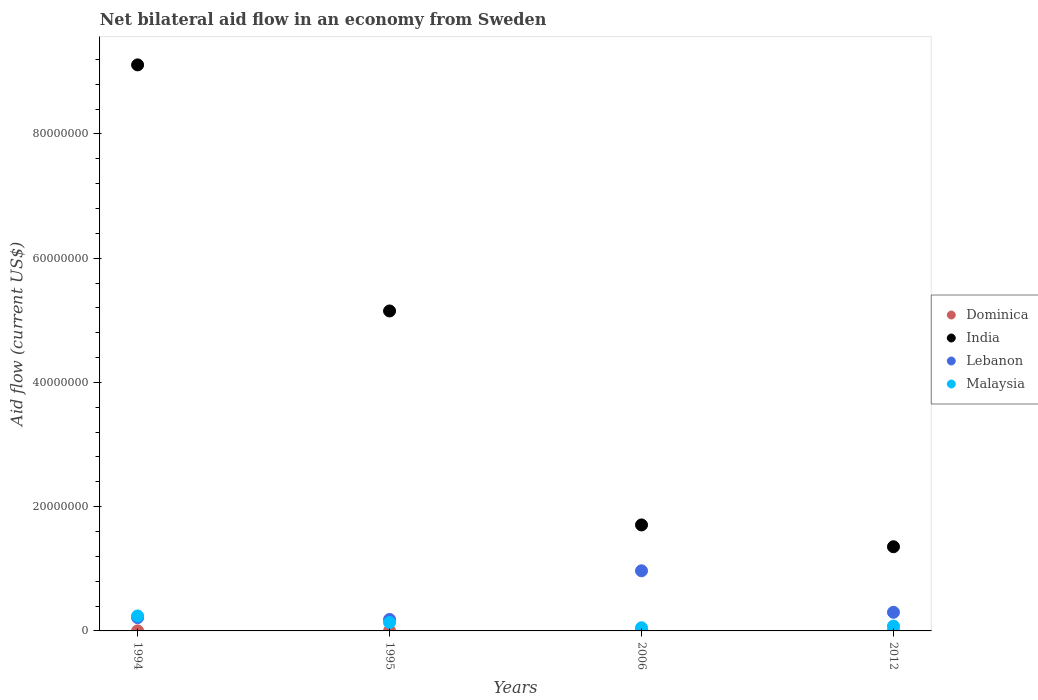How many different coloured dotlines are there?
Ensure brevity in your answer.  4. What is the net bilateral aid flow in India in 1995?
Ensure brevity in your answer.  5.15e+07. Across all years, what is the minimum net bilateral aid flow in Lebanon?
Your answer should be very brief. 1.85e+06. In which year was the net bilateral aid flow in India maximum?
Provide a succinct answer. 1994. What is the total net bilateral aid flow in Lebanon in the graph?
Give a very brief answer. 1.67e+07. What is the difference between the net bilateral aid flow in India in 1995 and that in 2012?
Your answer should be very brief. 3.80e+07. What is the difference between the net bilateral aid flow in Malaysia in 2006 and the net bilateral aid flow in India in 2012?
Offer a very short reply. -1.30e+07. What is the average net bilateral aid flow in Malaysia per year?
Keep it short and to the point. 1.26e+06. In the year 2006, what is the difference between the net bilateral aid flow in Malaysia and net bilateral aid flow in Lebanon?
Your response must be concise. -9.17e+06. In how many years, is the net bilateral aid flow in India greater than 16000000 US$?
Ensure brevity in your answer.  3. What is the ratio of the net bilateral aid flow in Lebanon in 1994 to that in 1995?
Give a very brief answer. 1.16. What is the difference between the highest and the second highest net bilateral aid flow in Lebanon?
Offer a very short reply. 6.68e+06. What is the difference between the highest and the lowest net bilateral aid flow in Dominica?
Provide a short and direct response. 2.00e+04. Is it the case that in every year, the sum of the net bilateral aid flow in Dominica and net bilateral aid flow in Lebanon  is greater than the net bilateral aid flow in India?
Ensure brevity in your answer.  No. Does the net bilateral aid flow in India monotonically increase over the years?
Provide a short and direct response. No. How many dotlines are there?
Make the answer very short. 4. Are the values on the major ticks of Y-axis written in scientific E-notation?
Provide a short and direct response. No. Does the graph contain grids?
Your answer should be very brief. No. Where does the legend appear in the graph?
Make the answer very short. Center right. How many legend labels are there?
Give a very brief answer. 4. What is the title of the graph?
Your answer should be very brief. Net bilateral aid flow in an economy from Sweden. Does "Kazakhstan" appear as one of the legend labels in the graph?
Give a very brief answer. No. What is the Aid flow (current US$) of India in 1994?
Your answer should be very brief. 9.11e+07. What is the Aid flow (current US$) in Lebanon in 1994?
Your response must be concise. 2.14e+06. What is the Aid flow (current US$) of Malaysia in 1994?
Offer a terse response. 2.41e+06. What is the Aid flow (current US$) in India in 1995?
Your answer should be very brief. 5.15e+07. What is the Aid flow (current US$) in Lebanon in 1995?
Ensure brevity in your answer.  1.85e+06. What is the Aid flow (current US$) in Malaysia in 1995?
Keep it short and to the point. 1.35e+06. What is the Aid flow (current US$) of Dominica in 2006?
Keep it short and to the point. 3.00e+04. What is the Aid flow (current US$) in India in 2006?
Provide a succinct answer. 1.71e+07. What is the Aid flow (current US$) of Lebanon in 2006?
Provide a succinct answer. 9.68e+06. What is the Aid flow (current US$) of Malaysia in 2006?
Offer a terse response. 5.10e+05. What is the Aid flow (current US$) in Dominica in 2012?
Keep it short and to the point. 2.00e+04. What is the Aid flow (current US$) of India in 2012?
Your answer should be compact. 1.36e+07. What is the Aid flow (current US$) of Malaysia in 2012?
Make the answer very short. 7.80e+05. Across all years, what is the maximum Aid flow (current US$) of Dominica?
Your answer should be compact. 3.00e+04. Across all years, what is the maximum Aid flow (current US$) in India?
Your answer should be very brief. 9.11e+07. Across all years, what is the maximum Aid flow (current US$) in Lebanon?
Make the answer very short. 9.68e+06. Across all years, what is the maximum Aid flow (current US$) of Malaysia?
Provide a short and direct response. 2.41e+06. Across all years, what is the minimum Aid flow (current US$) of Dominica?
Keep it short and to the point. 10000. Across all years, what is the minimum Aid flow (current US$) in India?
Provide a succinct answer. 1.36e+07. Across all years, what is the minimum Aid flow (current US$) of Lebanon?
Ensure brevity in your answer.  1.85e+06. Across all years, what is the minimum Aid flow (current US$) in Malaysia?
Give a very brief answer. 5.10e+05. What is the total Aid flow (current US$) of India in the graph?
Offer a terse response. 1.73e+08. What is the total Aid flow (current US$) of Lebanon in the graph?
Offer a terse response. 1.67e+07. What is the total Aid flow (current US$) in Malaysia in the graph?
Provide a short and direct response. 5.05e+06. What is the difference between the Aid flow (current US$) of Dominica in 1994 and that in 1995?
Make the answer very short. -10000. What is the difference between the Aid flow (current US$) of India in 1994 and that in 1995?
Make the answer very short. 3.96e+07. What is the difference between the Aid flow (current US$) of Malaysia in 1994 and that in 1995?
Keep it short and to the point. 1.06e+06. What is the difference between the Aid flow (current US$) of Dominica in 1994 and that in 2006?
Keep it short and to the point. -2.00e+04. What is the difference between the Aid flow (current US$) of India in 1994 and that in 2006?
Keep it short and to the point. 7.40e+07. What is the difference between the Aid flow (current US$) of Lebanon in 1994 and that in 2006?
Your response must be concise. -7.54e+06. What is the difference between the Aid flow (current US$) in Malaysia in 1994 and that in 2006?
Offer a very short reply. 1.90e+06. What is the difference between the Aid flow (current US$) in India in 1994 and that in 2012?
Keep it short and to the point. 7.76e+07. What is the difference between the Aid flow (current US$) in Lebanon in 1994 and that in 2012?
Give a very brief answer. -8.60e+05. What is the difference between the Aid flow (current US$) in Malaysia in 1994 and that in 2012?
Your answer should be compact. 1.63e+06. What is the difference between the Aid flow (current US$) in India in 1995 and that in 2006?
Your answer should be very brief. 3.44e+07. What is the difference between the Aid flow (current US$) of Lebanon in 1995 and that in 2006?
Ensure brevity in your answer.  -7.83e+06. What is the difference between the Aid flow (current US$) in Malaysia in 1995 and that in 2006?
Your answer should be compact. 8.40e+05. What is the difference between the Aid flow (current US$) in Dominica in 1995 and that in 2012?
Make the answer very short. 0. What is the difference between the Aid flow (current US$) in India in 1995 and that in 2012?
Make the answer very short. 3.80e+07. What is the difference between the Aid flow (current US$) in Lebanon in 1995 and that in 2012?
Ensure brevity in your answer.  -1.15e+06. What is the difference between the Aid flow (current US$) in Malaysia in 1995 and that in 2012?
Keep it short and to the point. 5.70e+05. What is the difference between the Aid flow (current US$) in Dominica in 2006 and that in 2012?
Provide a succinct answer. 10000. What is the difference between the Aid flow (current US$) of India in 2006 and that in 2012?
Provide a short and direct response. 3.51e+06. What is the difference between the Aid flow (current US$) in Lebanon in 2006 and that in 2012?
Offer a very short reply. 6.68e+06. What is the difference between the Aid flow (current US$) of Dominica in 1994 and the Aid flow (current US$) of India in 1995?
Make the answer very short. -5.15e+07. What is the difference between the Aid flow (current US$) in Dominica in 1994 and the Aid flow (current US$) in Lebanon in 1995?
Make the answer very short. -1.84e+06. What is the difference between the Aid flow (current US$) in Dominica in 1994 and the Aid flow (current US$) in Malaysia in 1995?
Offer a terse response. -1.34e+06. What is the difference between the Aid flow (current US$) in India in 1994 and the Aid flow (current US$) in Lebanon in 1995?
Offer a very short reply. 8.93e+07. What is the difference between the Aid flow (current US$) in India in 1994 and the Aid flow (current US$) in Malaysia in 1995?
Ensure brevity in your answer.  8.98e+07. What is the difference between the Aid flow (current US$) of Lebanon in 1994 and the Aid flow (current US$) of Malaysia in 1995?
Offer a terse response. 7.90e+05. What is the difference between the Aid flow (current US$) of Dominica in 1994 and the Aid flow (current US$) of India in 2006?
Ensure brevity in your answer.  -1.70e+07. What is the difference between the Aid flow (current US$) of Dominica in 1994 and the Aid flow (current US$) of Lebanon in 2006?
Your answer should be very brief. -9.67e+06. What is the difference between the Aid flow (current US$) in Dominica in 1994 and the Aid flow (current US$) in Malaysia in 2006?
Provide a short and direct response. -5.00e+05. What is the difference between the Aid flow (current US$) of India in 1994 and the Aid flow (current US$) of Lebanon in 2006?
Provide a short and direct response. 8.14e+07. What is the difference between the Aid flow (current US$) of India in 1994 and the Aid flow (current US$) of Malaysia in 2006?
Provide a succinct answer. 9.06e+07. What is the difference between the Aid flow (current US$) of Lebanon in 1994 and the Aid flow (current US$) of Malaysia in 2006?
Ensure brevity in your answer.  1.63e+06. What is the difference between the Aid flow (current US$) of Dominica in 1994 and the Aid flow (current US$) of India in 2012?
Your response must be concise. -1.35e+07. What is the difference between the Aid flow (current US$) in Dominica in 1994 and the Aid flow (current US$) in Lebanon in 2012?
Your response must be concise. -2.99e+06. What is the difference between the Aid flow (current US$) in Dominica in 1994 and the Aid flow (current US$) in Malaysia in 2012?
Your answer should be compact. -7.70e+05. What is the difference between the Aid flow (current US$) of India in 1994 and the Aid flow (current US$) of Lebanon in 2012?
Ensure brevity in your answer.  8.81e+07. What is the difference between the Aid flow (current US$) in India in 1994 and the Aid flow (current US$) in Malaysia in 2012?
Provide a succinct answer. 9.03e+07. What is the difference between the Aid flow (current US$) of Lebanon in 1994 and the Aid flow (current US$) of Malaysia in 2012?
Provide a succinct answer. 1.36e+06. What is the difference between the Aid flow (current US$) in Dominica in 1995 and the Aid flow (current US$) in India in 2006?
Provide a short and direct response. -1.70e+07. What is the difference between the Aid flow (current US$) in Dominica in 1995 and the Aid flow (current US$) in Lebanon in 2006?
Provide a short and direct response. -9.66e+06. What is the difference between the Aid flow (current US$) in Dominica in 1995 and the Aid flow (current US$) in Malaysia in 2006?
Offer a very short reply. -4.90e+05. What is the difference between the Aid flow (current US$) of India in 1995 and the Aid flow (current US$) of Lebanon in 2006?
Offer a very short reply. 4.18e+07. What is the difference between the Aid flow (current US$) in India in 1995 and the Aid flow (current US$) in Malaysia in 2006?
Your answer should be very brief. 5.10e+07. What is the difference between the Aid flow (current US$) of Lebanon in 1995 and the Aid flow (current US$) of Malaysia in 2006?
Ensure brevity in your answer.  1.34e+06. What is the difference between the Aid flow (current US$) of Dominica in 1995 and the Aid flow (current US$) of India in 2012?
Offer a terse response. -1.35e+07. What is the difference between the Aid flow (current US$) of Dominica in 1995 and the Aid flow (current US$) of Lebanon in 2012?
Make the answer very short. -2.98e+06. What is the difference between the Aid flow (current US$) of Dominica in 1995 and the Aid flow (current US$) of Malaysia in 2012?
Give a very brief answer. -7.60e+05. What is the difference between the Aid flow (current US$) of India in 1995 and the Aid flow (current US$) of Lebanon in 2012?
Make the answer very short. 4.85e+07. What is the difference between the Aid flow (current US$) in India in 1995 and the Aid flow (current US$) in Malaysia in 2012?
Keep it short and to the point. 5.07e+07. What is the difference between the Aid flow (current US$) of Lebanon in 1995 and the Aid flow (current US$) of Malaysia in 2012?
Your response must be concise. 1.07e+06. What is the difference between the Aid flow (current US$) in Dominica in 2006 and the Aid flow (current US$) in India in 2012?
Your answer should be very brief. -1.35e+07. What is the difference between the Aid flow (current US$) in Dominica in 2006 and the Aid flow (current US$) in Lebanon in 2012?
Your response must be concise. -2.97e+06. What is the difference between the Aid flow (current US$) of Dominica in 2006 and the Aid flow (current US$) of Malaysia in 2012?
Give a very brief answer. -7.50e+05. What is the difference between the Aid flow (current US$) of India in 2006 and the Aid flow (current US$) of Lebanon in 2012?
Offer a very short reply. 1.41e+07. What is the difference between the Aid flow (current US$) in India in 2006 and the Aid flow (current US$) in Malaysia in 2012?
Your answer should be very brief. 1.63e+07. What is the difference between the Aid flow (current US$) of Lebanon in 2006 and the Aid flow (current US$) of Malaysia in 2012?
Your answer should be very brief. 8.90e+06. What is the average Aid flow (current US$) of Dominica per year?
Provide a short and direct response. 2.00e+04. What is the average Aid flow (current US$) of India per year?
Give a very brief answer. 4.33e+07. What is the average Aid flow (current US$) of Lebanon per year?
Ensure brevity in your answer.  4.17e+06. What is the average Aid flow (current US$) of Malaysia per year?
Offer a very short reply. 1.26e+06. In the year 1994, what is the difference between the Aid flow (current US$) in Dominica and Aid flow (current US$) in India?
Keep it short and to the point. -9.11e+07. In the year 1994, what is the difference between the Aid flow (current US$) of Dominica and Aid flow (current US$) of Lebanon?
Your answer should be compact. -2.13e+06. In the year 1994, what is the difference between the Aid flow (current US$) in Dominica and Aid flow (current US$) in Malaysia?
Give a very brief answer. -2.40e+06. In the year 1994, what is the difference between the Aid flow (current US$) of India and Aid flow (current US$) of Lebanon?
Offer a very short reply. 8.90e+07. In the year 1994, what is the difference between the Aid flow (current US$) of India and Aid flow (current US$) of Malaysia?
Provide a succinct answer. 8.87e+07. In the year 1995, what is the difference between the Aid flow (current US$) of Dominica and Aid flow (current US$) of India?
Your answer should be compact. -5.15e+07. In the year 1995, what is the difference between the Aid flow (current US$) in Dominica and Aid flow (current US$) in Lebanon?
Keep it short and to the point. -1.83e+06. In the year 1995, what is the difference between the Aid flow (current US$) of Dominica and Aid flow (current US$) of Malaysia?
Provide a short and direct response. -1.33e+06. In the year 1995, what is the difference between the Aid flow (current US$) of India and Aid flow (current US$) of Lebanon?
Offer a terse response. 4.96e+07. In the year 1995, what is the difference between the Aid flow (current US$) of India and Aid flow (current US$) of Malaysia?
Give a very brief answer. 5.02e+07. In the year 2006, what is the difference between the Aid flow (current US$) in Dominica and Aid flow (current US$) in India?
Your answer should be compact. -1.70e+07. In the year 2006, what is the difference between the Aid flow (current US$) of Dominica and Aid flow (current US$) of Lebanon?
Offer a terse response. -9.65e+06. In the year 2006, what is the difference between the Aid flow (current US$) of Dominica and Aid flow (current US$) of Malaysia?
Give a very brief answer. -4.80e+05. In the year 2006, what is the difference between the Aid flow (current US$) of India and Aid flow (current US$) of Lebanon?
Ensure brevity in your answer.  7.38e+06. In the year 2006, what is the difference between the Aid flow (current US$) of India and Aid flow (current US$) of Malaysia?
Your answer should be very brief. 1.66e+07. In the year 2006, what is the difference between the Aid flow (current US$) of Lebanon and Aid flow (current US$) of Malaysia?
Give a very brief answer. 9.17e+06. In the year 2012, what is the difference between the Aid flow (current US$) of Dominica and Aid flow (current US$) of India?
Keep it short and to the point. -1.35e+07. In the year 2012, what is the difference between the Aid flow (current US$) of Dominica and Aid flow (current US$) of Lebanon?
Your answer should be very brief. -2.98e+06. In the year 2012, what is the difference between the Aid flow (current US$) in Dominica and Aid flow (current US$) in Malaysia?
Give a very brief answer. -7.60e+05. In the year 2012, what is the difference between the Aid flow (current US$) of India and Aid flow (current US$) of Lebanon?
Make the answer very short. 1.06e+07. In the year 2012, what is the difference between the Aid flow (current US$) in India and Aid flow (current US$) in Malaysia?
Make the answer very short. 1.28e+07. In the year 2012, what is the difference between the Aid flow (current US$) in Lebanon and Aid flow (current US$) in Malaysia?
Your answer should be compact. 2.22e+06. What is the ratio of the Aid flow (current US$) of India in 1994 to that in 1995?
Make the answer very short. 1.77. What is the ratio of the Aid flow (current US$) of Lebanon in 1994 to that in 1995?
Your response must be concise. 1.16. What is the ratio of the Aid flow (current US$) in Malaysia in 1994 to that in 1995?
Offer a very short reply. 1.79. What is the ratio of the Aid flow (current US$) in Dominica in 1994 to that in 2006?
Ensure brevity in your answer.  0.33. What is the ratio of the Aid flow (current US$) in India in 1994 to that in 2006?
Provide a succinct answer. 5.34. What is the ratio of the Aid flow (current US$) in Lebanon in 1994 to that in 2006?
Your response must be concise. 0.22. What is the ratio of the Aid flow (current US$) in Malaysia in 1994 to that in 2006?
Your answer should be very brief. 4.73. What is the ratio of the Aid flow (current US$) of Dominica in 1994 to that in 2012?
Offer a terse response. 0.5. What is the ratio of the Aid flow (current US$) in India in 1994 to that in 2012?
Your answer should be very brief. 6.72. What is the ratio of the Aid flow (current US$) of Lebanon in 1994 to that in 2012?
Make the answer very short. 0.71. What is the ratio of the Aid flow (current US$) in Malaysia in 1994 to that in 2012?
Make the answer very short. 3.09. What is the ratio of the Aid flow (current US$) in India in 1995 to that in 2006?
Make the answer very short. 3.02. What is the ratio of the Aid flow (current US$) of Lebanon in 1995 to that in 2006?
Offer a terse response. 0.19. What is the ratio of the Aid flow (current US$) in Malaysia in 1995 to that in 2006?
Your answer should be very brief. 2.65. What is the ratio of the Aid flow (current US$) in India in 1995 to that in 2012?
Offer a terse response. 3.8. What is the ratio of the Aid flow (current US$) of Lebanon in 1995 to that in 2012?
Offer a very short reply. 0.62. What is the ratio of the Aid flow (current US$) of Malaysia in 1995 to that in 2012?
Ensure brevity in your answer.  1.73. What is the ratio of the Aid flow (current US$) of Dominica in 2006 to that in 2012?
Offer a terse response. 1.5. What is the ratio of the Aid flow (current US$) in India in 2006 to that in 2012?
Keep it short and to the point. 1.26. What is the ratio of the Aid flow (current US$) in Lebanon in 2006 to that in 2012?
Offer a terse response. 3.23. What is the ratio of the Aid flow (current US$) in Malaysia in 2006 to that in 2012?
Provide a short and direct response. 0.65. What is the difference between the highest and the second highest Aid flow (current US$) of India?
Your answer should be very brief. 3.96e+07. What is the difference between the highest and the second highest Aid flow (current US$) in Lebanon?
Your answer should be compact. 6.68e+06. What is the difference between the highest and the second highest Aid flow (current US$) of Malaysia?
Make the answer very short. 1.06e+06. What is the difference between the highest and the lowest Aid flow (current US$) in India?
Offer a terse response. 7.76e+07. What is the difference between the highest and the lowest Aid flow (current US$) of Lebanon?
Provide a succinct answer. 7.83e+06. What is the difference between the highest and the lowest Aid flow (current US$) in Malaysia?
Provide a succinct answer. 1.90e+06. 